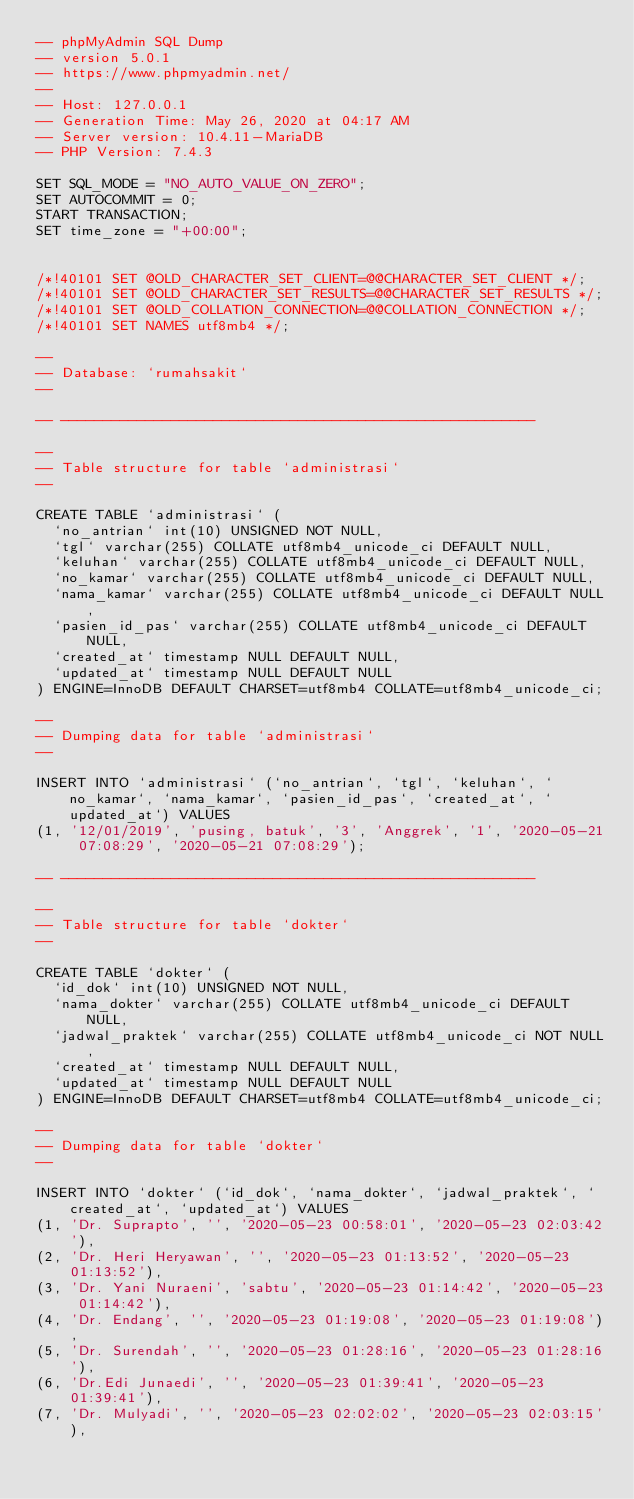<code> <loc_0><loc_0><loc_500><loc_500><_SQL_>-- phpMyAdmin SQL Dump
-- version 5.0.1
-- https://www.phpmyadmin.net/
--
-- Host: 127.0.0.1
-- Generation Time: May 26, 2020 at 04:17 AM
-- Server version: 10.4.11-MariaDB
-- PHP Version: 7.4.3

SET SQL_MODE = "NO_AUTO_VALUE_ON_ZERO";
SET AUTOCOMMIT = 0;
START TRANSACTION;
SET time_zone = "+00:00";


/*!40101 SET @OLD_CHARACTER_SET_CLIENT=@@CHARACTER_SET_CLIENT */;
/*!40101 SET @OLD_CHARACTER_SET_RESULTS=@@CHARACTER_SET_RESULTS */;
/*!40101 SET @OLD_COLLATION_CONNECTION=@@COLLATION_CONNECTION */;
/*!40101 SET NAMES utf8mb4 */;

--
-- Database: `rumahsakit`
--

-- --------------------------------------------------------

--
-- Table structure for table `administrasi`
--

CREATE TABLE `administrasi` (
  `no_antrian` int(10) UNSIGNED NOT NULL,
  `tgl` varchar(255) COLLATE utf8mb4_unicode_ci DEFAULT NULL,
  `keluhan` varchar(255) COLLATE utf8mb4_unicode_ci DEFAULT NULL,
  `no_kamar` varchar(255) COLLATE utf8mb4_unicode_ci DEFAULT NULL,
  `nama_kamar` varchar(255) COLLATE utf8mb4_unicode_ci DEFAULT NULL,
  `pasien_id_pas` varchar(255) COLLATE utf8mb4_unicode_ci DEFAULT NULL,
  `created_at` timestamp NULL DEFAULT NULL,
  `updated_at` timestamp NULL DEFAULT NULL
) ENGINE=InnoDB DEFAULT CHARSET=utf8mb4 COLLATE=utf8mb4_unicode_ci;

--
-- Dumping data for table `administrasi`
--

INSERT INTO `administrasi` (`no_antrian`, `tgl`, `keluhan`, `no_kamar`, `nama_kamar`, `pasien_id_pas`, `created_at`, `updated_at`) VALUES
(1, '12/01/2019', 'pusing, batuk', '3', 'Anggrek', '1', '2020-05-21 07:08:29', '2020-05-21 07:08:29');

-- --------------------------------------------------------

--
-- Table structure for table `dokter`
--

CREATE TABLE `dokter` (
  `id_dok` int(10) UNSIGNED NOT NULL,
  `nama_dokter` varchar(255) COLLATE utf8mb4_unicode_ci DEFAULT NULL,
  `jadwal_praktek` varchar(255) COLLATE utf8mb4_unicode_ci NOT NULL,
  `created_at` timestamp NULL DEFAULT NULL,
  `updated_at` timestamp NULL DEFAULT NULL
) ENGINE=InnoDB DEFAULT CHARSET=utf8mb4 COLLATE=utf8mb4_unicode_ci;

--
-- Dumping data for table `dokter`
--

INSERT INTO `dokter` (`id_dok`, `nama_dokter`, `jadwal_praktek`, `created_at`, `updated_at`) VALUES
(1, 'Dr. Suprapto', '', '2020-05-23 00:58:01', '2020-05-23 02:03:42'),
(2, 'Dr. Heri Heryawan', '', '2020-05-23 01:13:52', '2020-05-23 01:13:52'),
(3, 'Dr. Yani Nuraeni', 'sabtu', '2020-05-23 01:14:42', '2020-05-23 01:14:42'),
(4, 'Dr. Endang', '', '2020-05-23 01:19:08', '2020-05-23 01:19:08'),
(5, 'Dr. Surendah', '', '2020-05-23 01:28:16', '2020-05-23 01:28:16'),
(6, 'Dr.Edi Junaedi', '', '2020-05-23 01:39:41', '2020-05-23 01:39:41'),
(7, 'Dr. Mulyadi', '', '2020-05-23 02:02:02', '2020-05-23 02:03:15'),</code> 